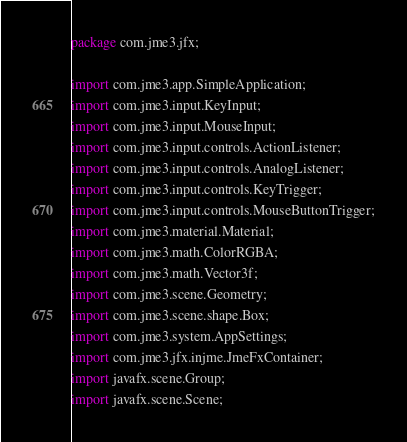<code> <loc_0><loc_0><loc_500><loc_500><_Java_>package com.jme3.jfx;

import com.jme3.app.SimpleApplication;
import com.jme3.input.KeyInput;
import com.jme3.input.MouseInput;
import com.jme3.input.controls.ActionListener;
import com.jme3.input.controls.AnalogListener;
import com.jme3.input.controls.KeyTrigger;
import com.jme3.input.controls.MouseButtonTrigger;
import com.jme3.material.Material;
import com.jme3.math.ColorRGBA;
import com.jme3.math.Vector3f;
import com.jme3.scene.Geometry;
import com.jme3.scene.shape.Box;
import com.jme3.system.AppSettings;
import com.jme3.jfx.injme.JmeFxContainer;
import javafx.scene.Group;
import javafx.scene.Scene;</code> 